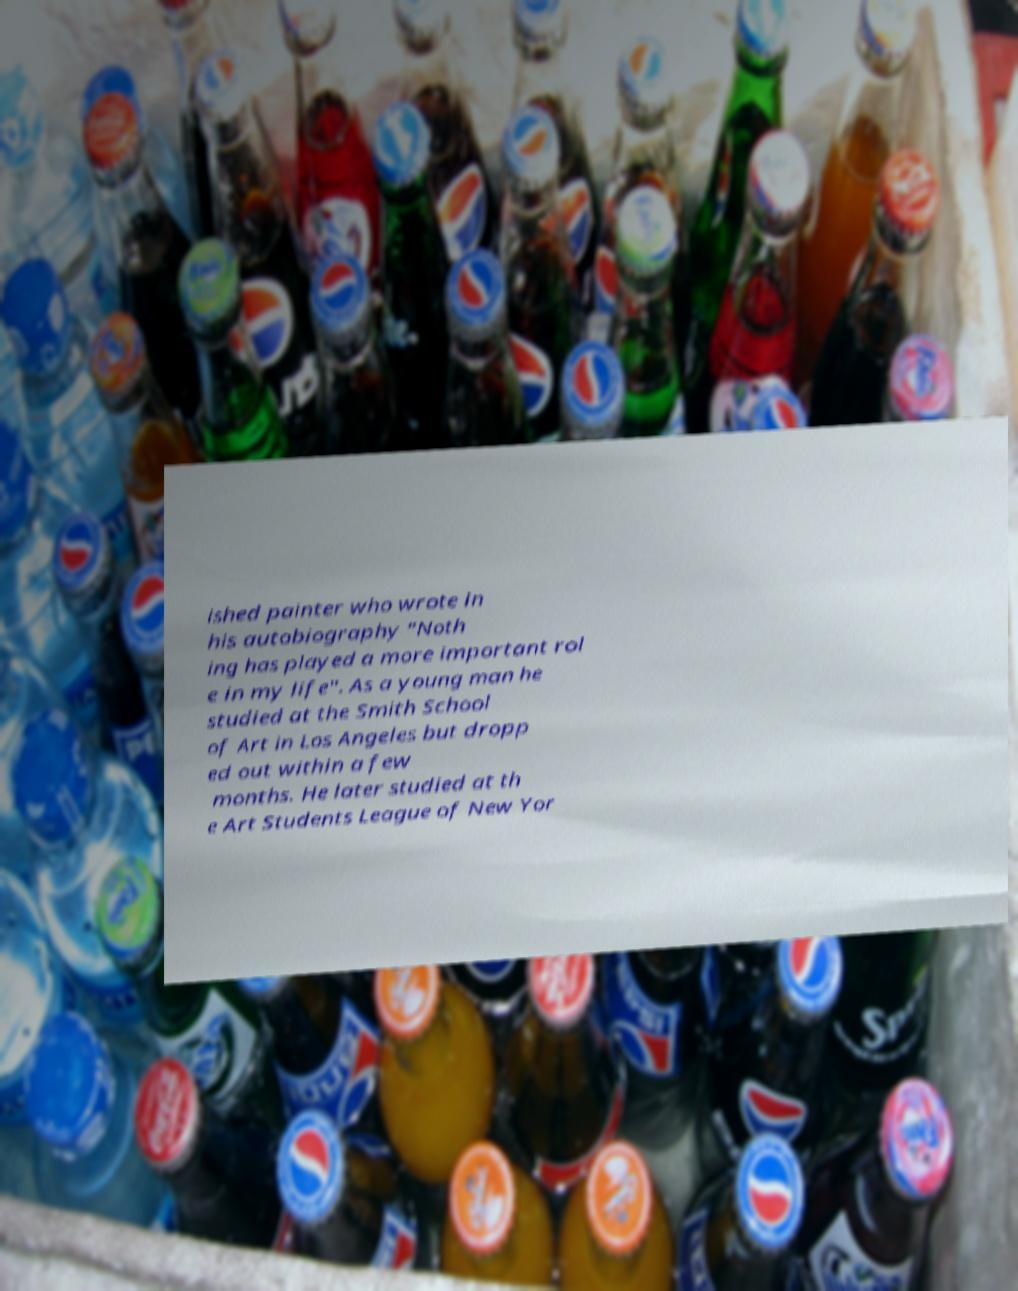Please identify and transcribe the text found in this image. ished painter who wrote in his autobiography "Noth ing has played a more important rol e in my life". As a young man he studied at the Smith School of Art in Los Angeles but dropp ed out within a few months. He later studied at th e Art Students League of New Yor 